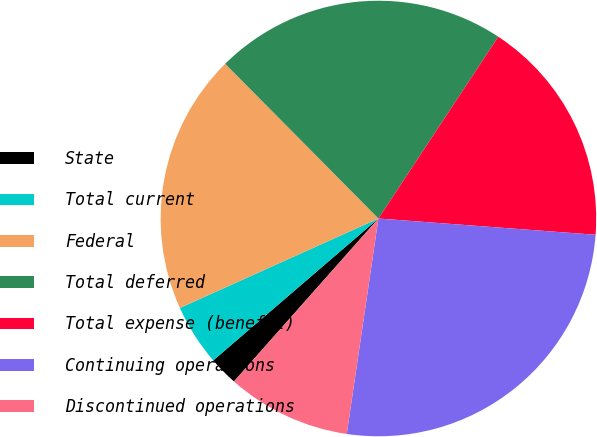Convert chart. <chart><loc_0><loc_0><loc_500><loc_500><pie_chart><fcel>State<fcel>Total current<fcel>Federal<fcel>Total deferred<fcel>Total expense (benefit)<fcel>Continuing operations<fcel>Discontinued operations<nl><fcel>2.16%<fcel>4.56%<fcel>19.31%<fcel>21.7%<fcel>16.91%<fcel>26.13%<fcel>9.22%<nl></chart> 